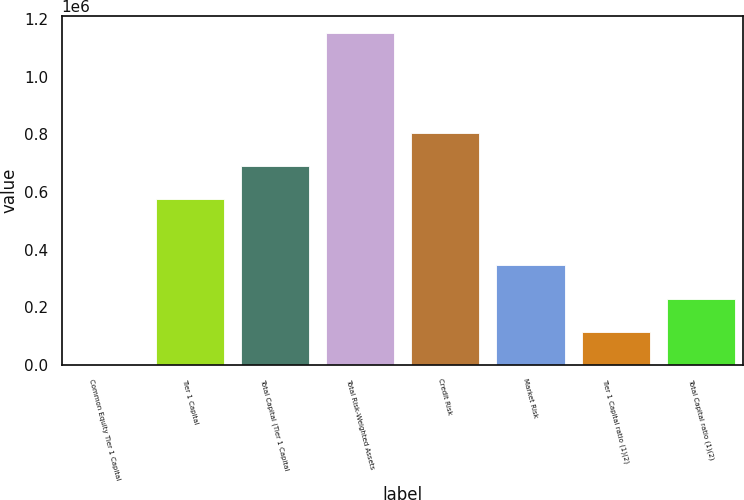Convert chart to OTSL. <chart><loc_0><loc_0><loc_500><loc_500><bar_chart><fcel>Common Equity Tier 1 Capital<fcel>Tier 1 Capital<fcel>Total Capital (Tier 1 Capital<fcel>Total Risk-Weighted Assets<fcel>Credit Risk<fcel>Market Risk<fcel>Tier 1 Capital ratio (1)(2)<fcel>Total Capital ratio (1)(2)<nl><fcel>12.39<fcel>576328<fcel>691591<fcel>1.15264e+06<fcel>806855<fcel>345802<fcel>115276<fcel>230539<nl></chart> 